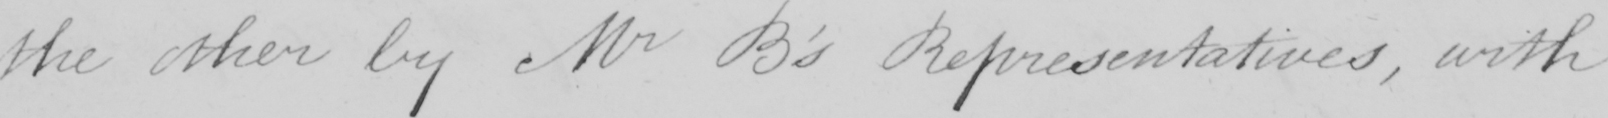What does this handwritten line say? the other by Mr B ' s Representatives , with 